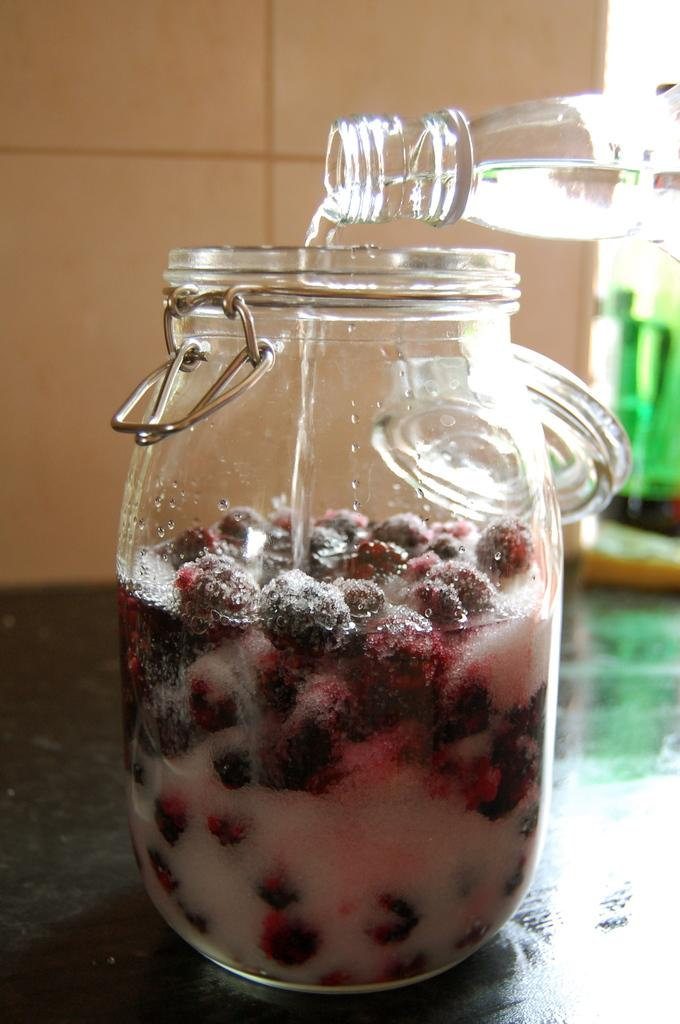What object is present in the image that contains something? There is a jar in the image, and it contains berries. What else can be seen in the image besides the jar? There is a water bottle in the image. What is the water bottle doing in the image? The water bottle is pouring water into the jar. What type of music can be heard coming from the jar in the image? There is no music present in the image; it features a jar of berries and a water bottle pouring water into the jar. 